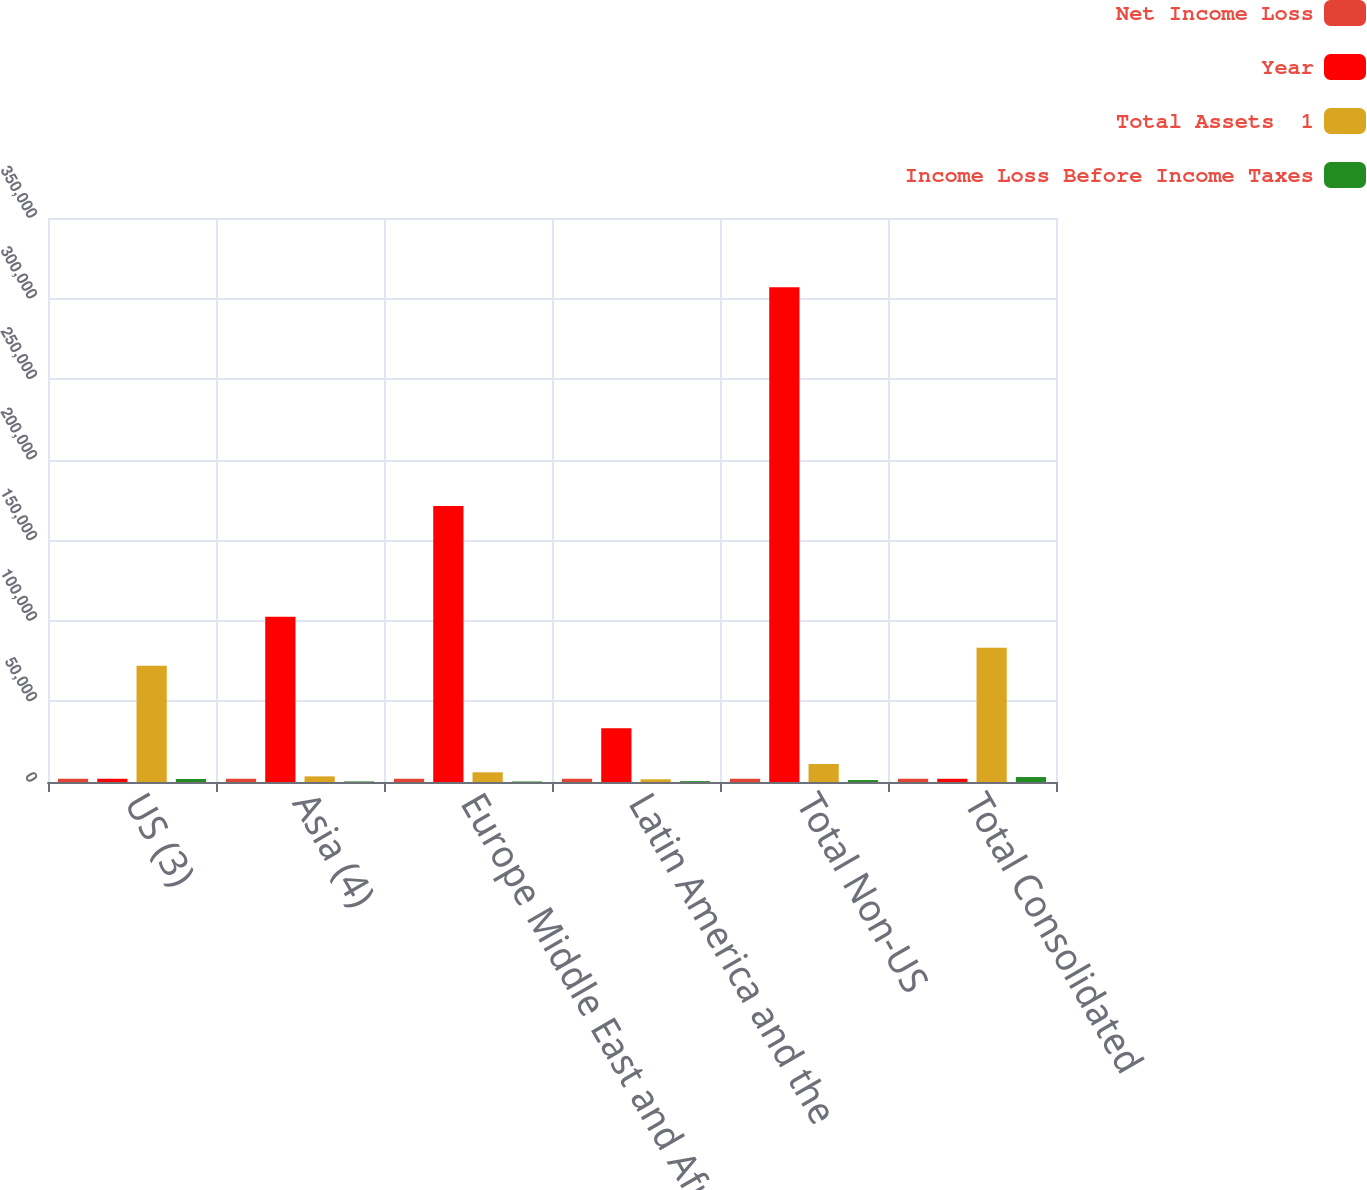<chart> <loc_0><loc_0><loc_500><loc_500><stacked_bar_chart><ecel><fcel>US (3)<fcel>Asia (4)<fcel>Europe Middle East and Africa<fcel>Latin America and the<fcel>Total Non-US<fcel>Total Consolidated<nl><fcel>Net Income Loss<fcel>2012<fcel>2012<fcel>2012<fcel>2012<fcel>2012<fcel>2012<nl><fcel>Year<fcel>2012<fcel>102492<fcel>171209<fcel>33327<fcel>307028<fcel>2012<nl><fcel>Total Assets  1<fcel>72175<fcel>3478<fcel>6011<fcel>1670<fcel>11159<fcel>83334<nl><fcel>Income Loss Before Income Taxes<fcel>1867<fcel>353<fcel>323<fcel>529<fcel>1205<fcel>3072<nl></chart> 